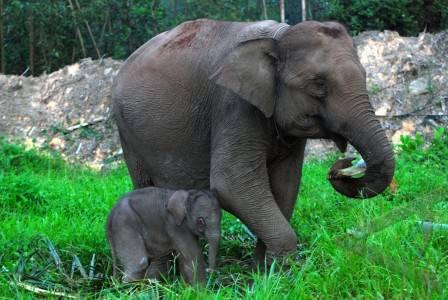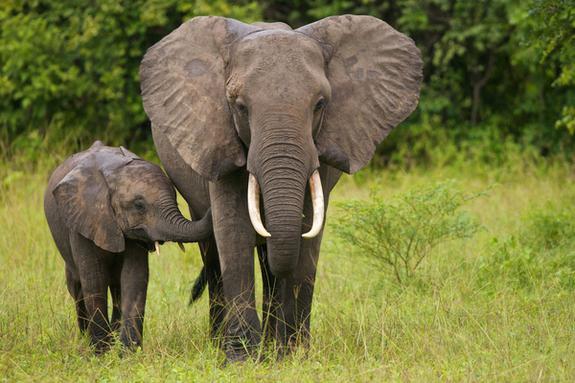The first image is the image on the left, the second image is the image on the right. Evaluate the accuracy of this statement regarding the images: "There is one animal in the image on the right.". Is it true? Answer yes or no. No. 